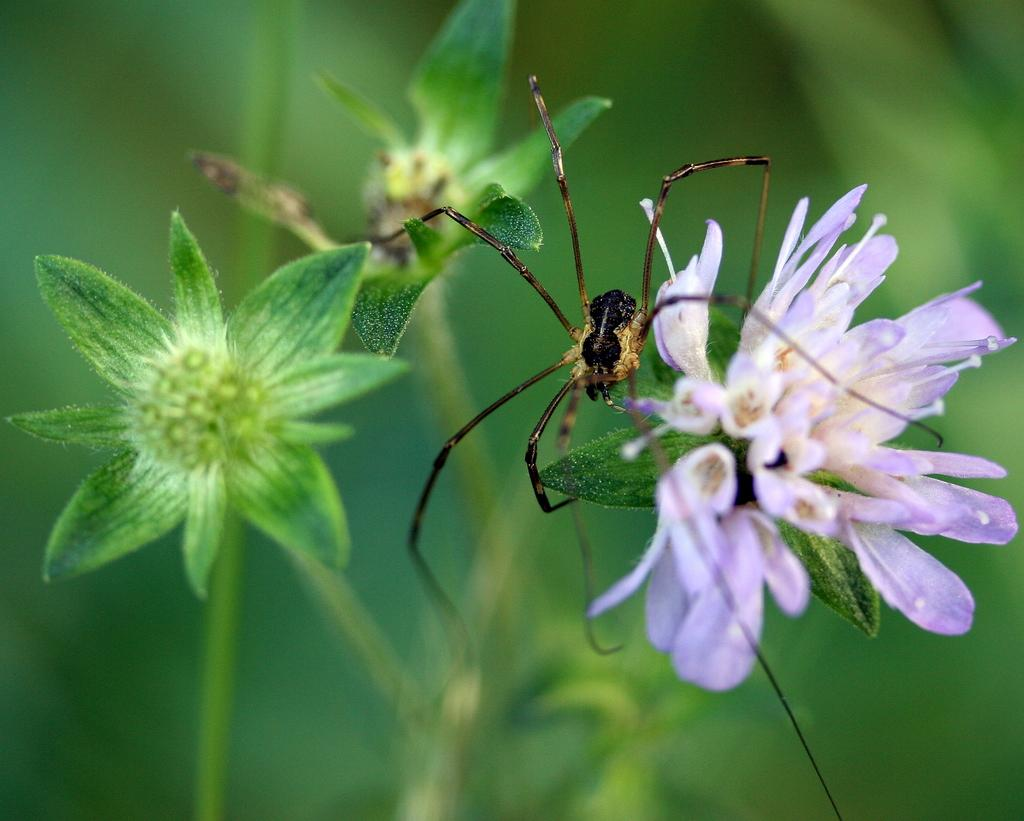What type of creature can be seen in the image? There is an insect in the image. What other elements are present in the image besides the insect? There are flowers in the image. Can you describe the background of the image? The background of the image is blurred. What discovery did the insect's dad make in the garden? There is no mention of a discovery, the insect's dad, or a garden in the image. 